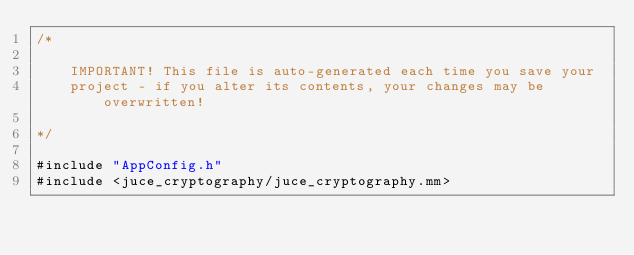<code> <loc_0><loc_0><loc_500><loc_500><_ObjectiveC_>/*

    IMPORTANT! This file is auto-generated each time you save your
    project - if you alter its contents, your changes may be overwritten!

*/

#include "AppConfig.h"
#include <juce_cryptography/juce_cryptography.mm>
</code> 